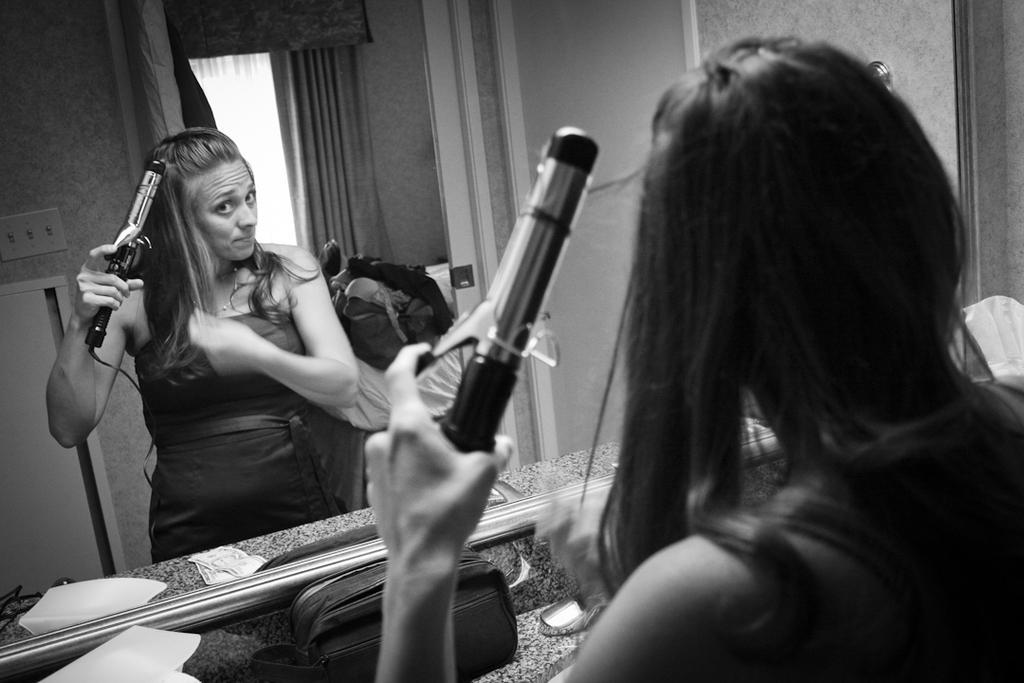Could you give a brief overview of what you see in this image? In this image we can see a lady standing and holding a hair straightener. There is a counter top and we can see a bag, napkin and some objects placed on the counter top. There is a mirror. 